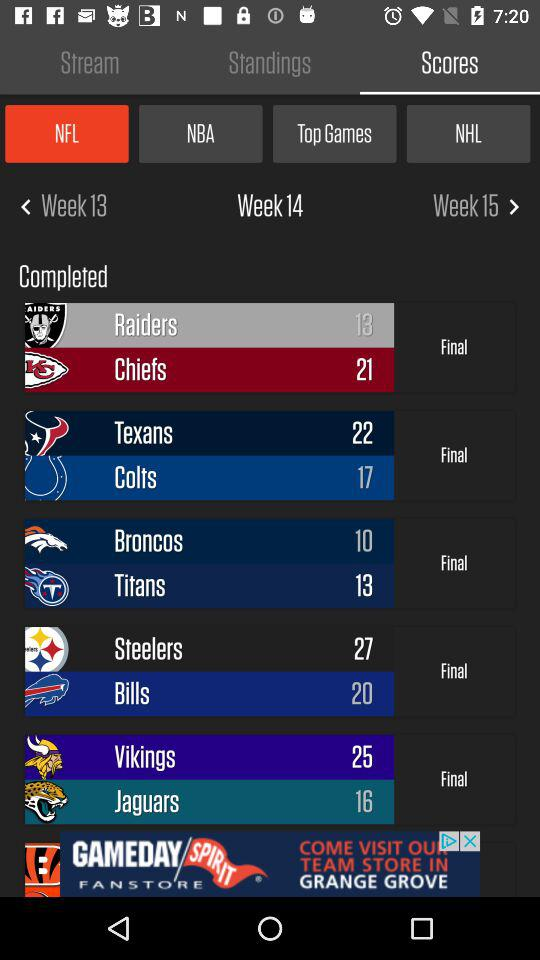What is the selected week? The selected week is "Week 14". 